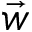Convert formula to latex. <formula><loc_0><loc_0><loc_500><loc_500>\vec { w }</formula> 